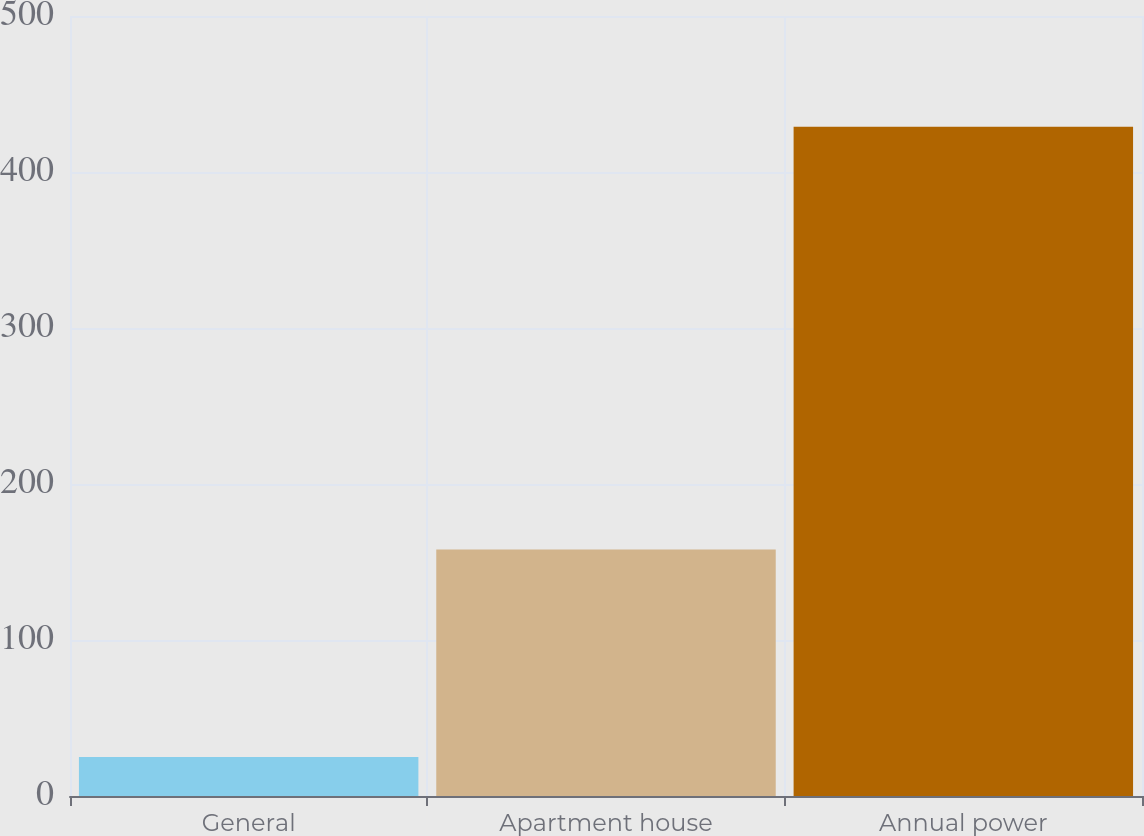Convert chart to OTSL. <chart><loc_0><loc_0><loc_500><loc_500><bar_chart><fcel>General<fcel>Apartment house<fcel>Annual power<nl><fcel>25<fcel>158<fcel>429<nl></chart> 